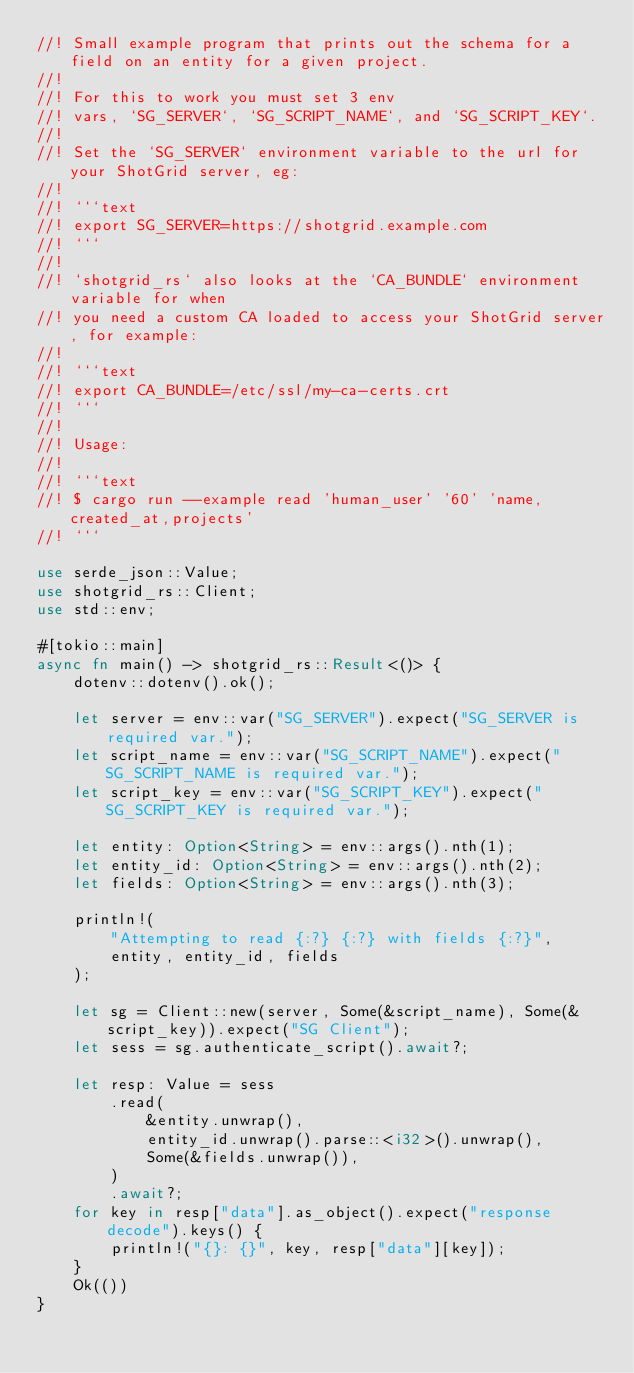<code> <loc_0><loc_0><loc_500><loc_500><_Rust_>//! Small example program that prints out the schema for a field on an entity for a given project.
//!
//! For this to work you must set 3 env
//! vars, `SG_SERVER`, `SG_SCRIPT_NAME`, and `SG_SCRIPT_KEY`.
//!
//! Set the `SG_SERVER` environment variable to the url for your ShotGrid server, eg:
//!
//! ```text
//! export SG_SERVER=https://shotgrid.example.com
//! ```
//!
//! `shotgrid_rs` also looks at the `CA_BUNDLE` environment variable for when
//! you need a custom CA loaded to access your ShotGrid server, for example:
//!
//! ```text
//! export CA_BUNDLE=/etc/ssl/my-ca-certs.crt
//! ```
//!
//! Usage:
//!
//! ```text
//! $ cargo run --example read 'human_user' '60' 'name,created_at,projects'
//! ```

use serde_json::Value;
use shotgrid_rs::Client;
use std::env;

#[tokio::main]
async fn main() -> shotgrid_rs::Result<()> {
    dotenv::dotenv().ok();

    let server = env::var("SG_SERVER").expect("SG_SERVER is required var.");
    let script_name = env::var("SG_SCRIPT_NAME").expect("SG_SCRIPT_NAME is required var.");
    let script_key = env::var("SG_SCRIPT_KEY").expect("SG_SCRIPT_KEY is required var.");

    let entity: Option<String> = env::args().nth(1);
    let entity_id: Option<String> = env::args().nth(2);
    let fields: Option<String> = env::args().nth(3);

    println!(
        "Attempting to read {:?} {:?} with fields {:?}",
        entity, entity_id, fields
    );

    let sg = Client::new(server, Some(&script_name), Some(&script_key)).expect("SG Client");
    let sess = sg.authenticate_script().await?;

    let resp: Value = sess
        .read(
            &entity.unwrap(),
            entity_id.unwrap().parse::<i32>().unwrap(),
            Some(&fields.unwrap()),
        )
        .await?;
    for key in resp["data"].as_object().expect("response decode").keys() {
        println!("{}: {}", key, resp["data"][key]);
    }
    Ok(())
}
</code> 